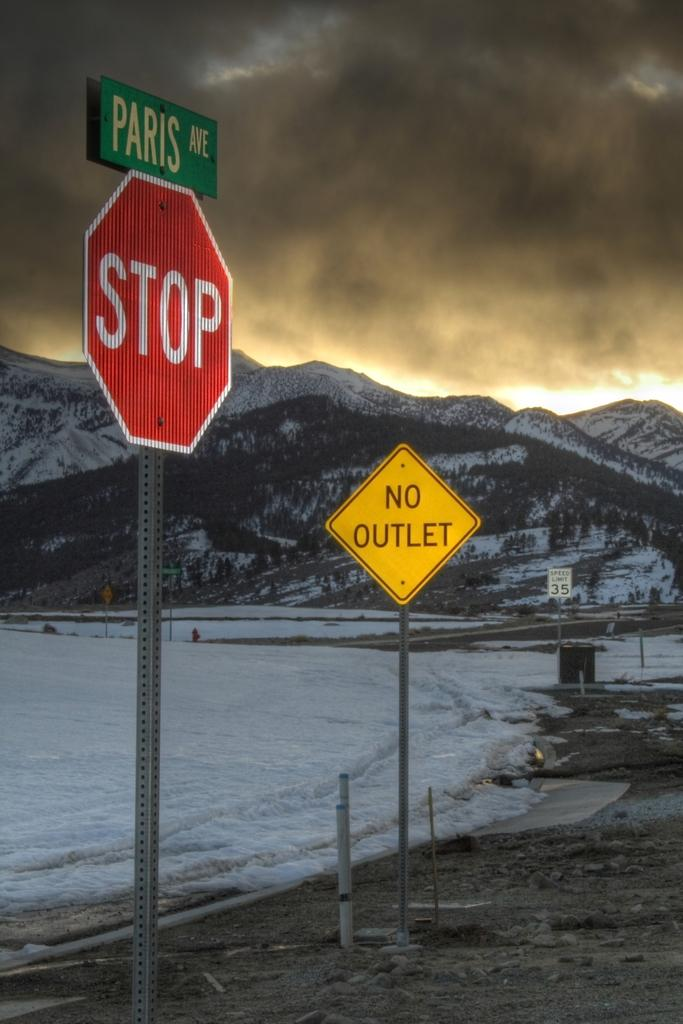<image>
Summarize the visual content of the image. A Paris Ave street sign above a stop sign. 